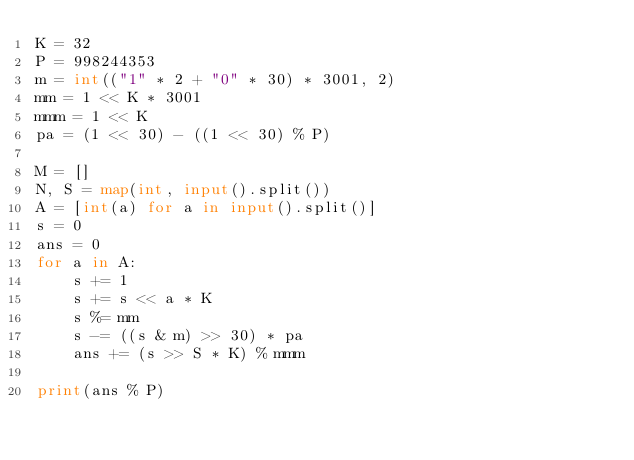<code> <loc_0><loc_0><loc_500><loc_500><_Python_>K = 32
P = 998244353
m = int(("1" * 2 + "0" * 30) * 3001, 2)
mm = 1 << K * 3001
mmm = 1 << K
pa = (1 << 30) - ((1 << 30) % P)

M = []
N, S = map(int, input().split())
A = [int(a) for a in input().split()]
s = 0
ans = 0
for a in A:
    s += 1
    s += s << a * K
    s %= mm
    s -= ((s & m) >> 30) * pa
    ans += (s >> S * K) % mmm

print(ans % P)</code> 